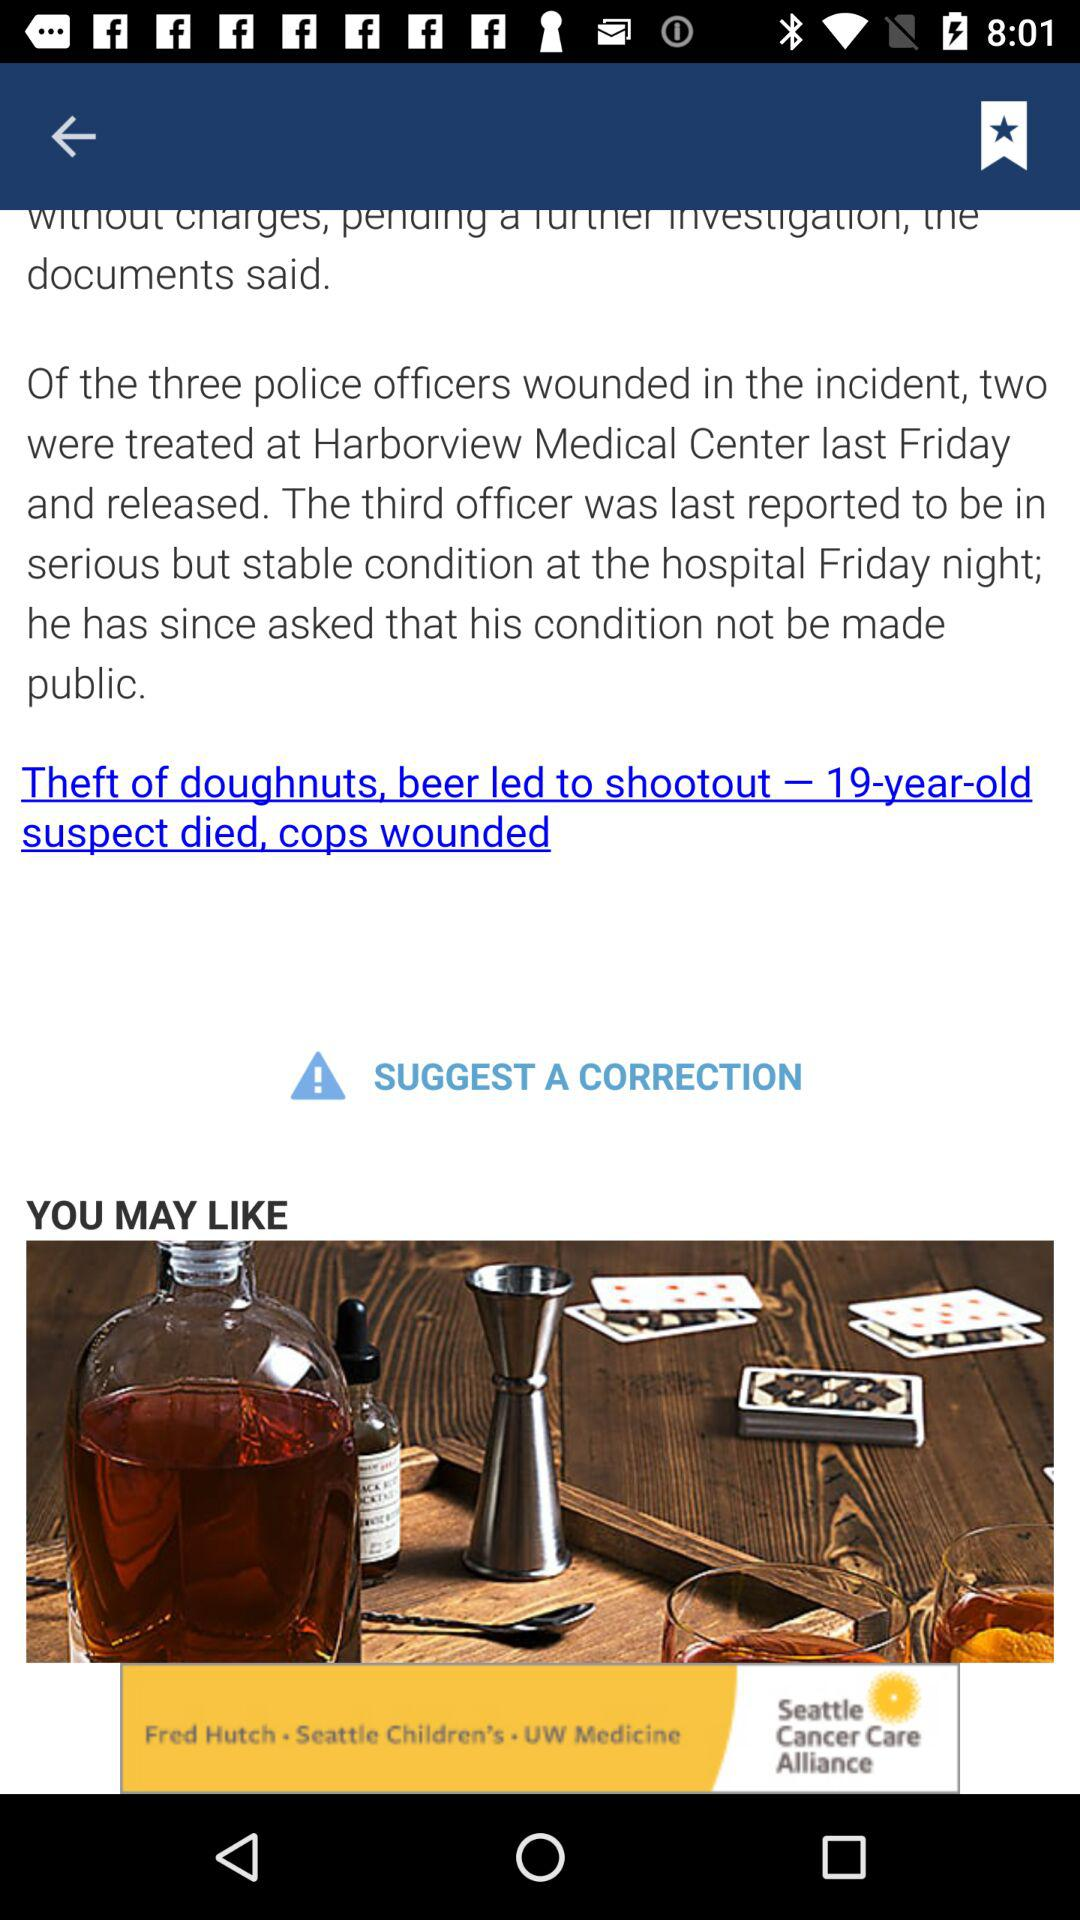How many police officers were wounded? There were three police officers wounded. 